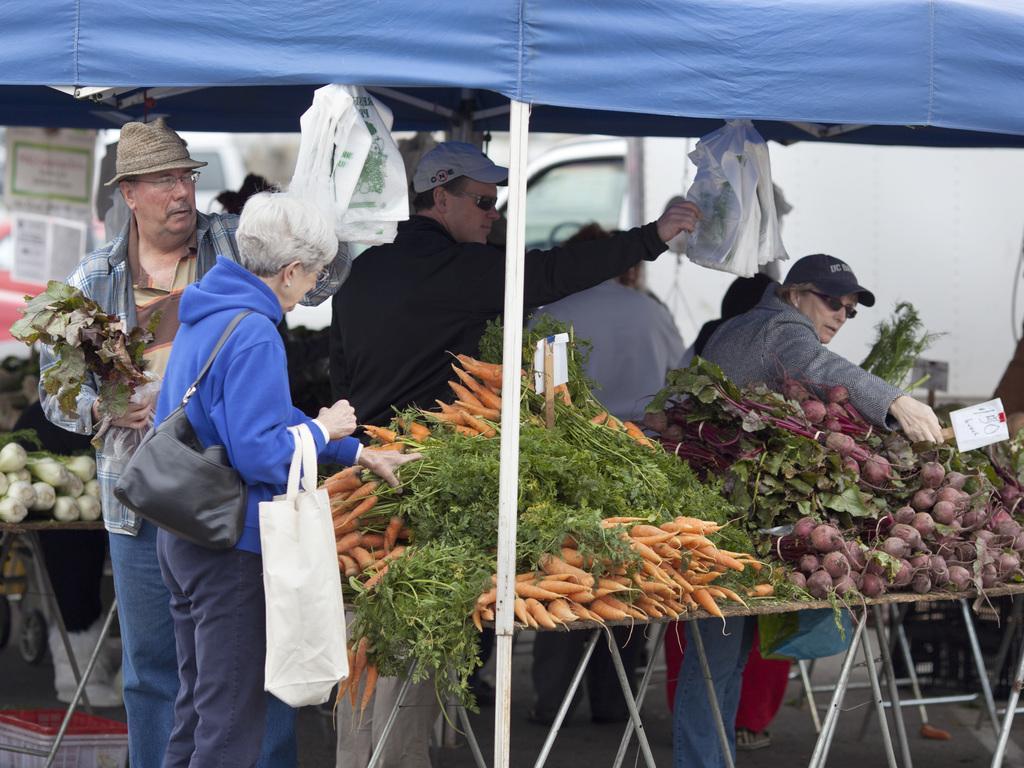Please provide a concise description of this image. In this picture there is a old woman wearing a blue color top and holding the white cover, taking the vegetables. Beside there is a old man standing and looking her. Behind there are some persons who are taking the vegetable. In the background there is a white color van. On the front bottom side there is a table full with carrots and beetroots. 